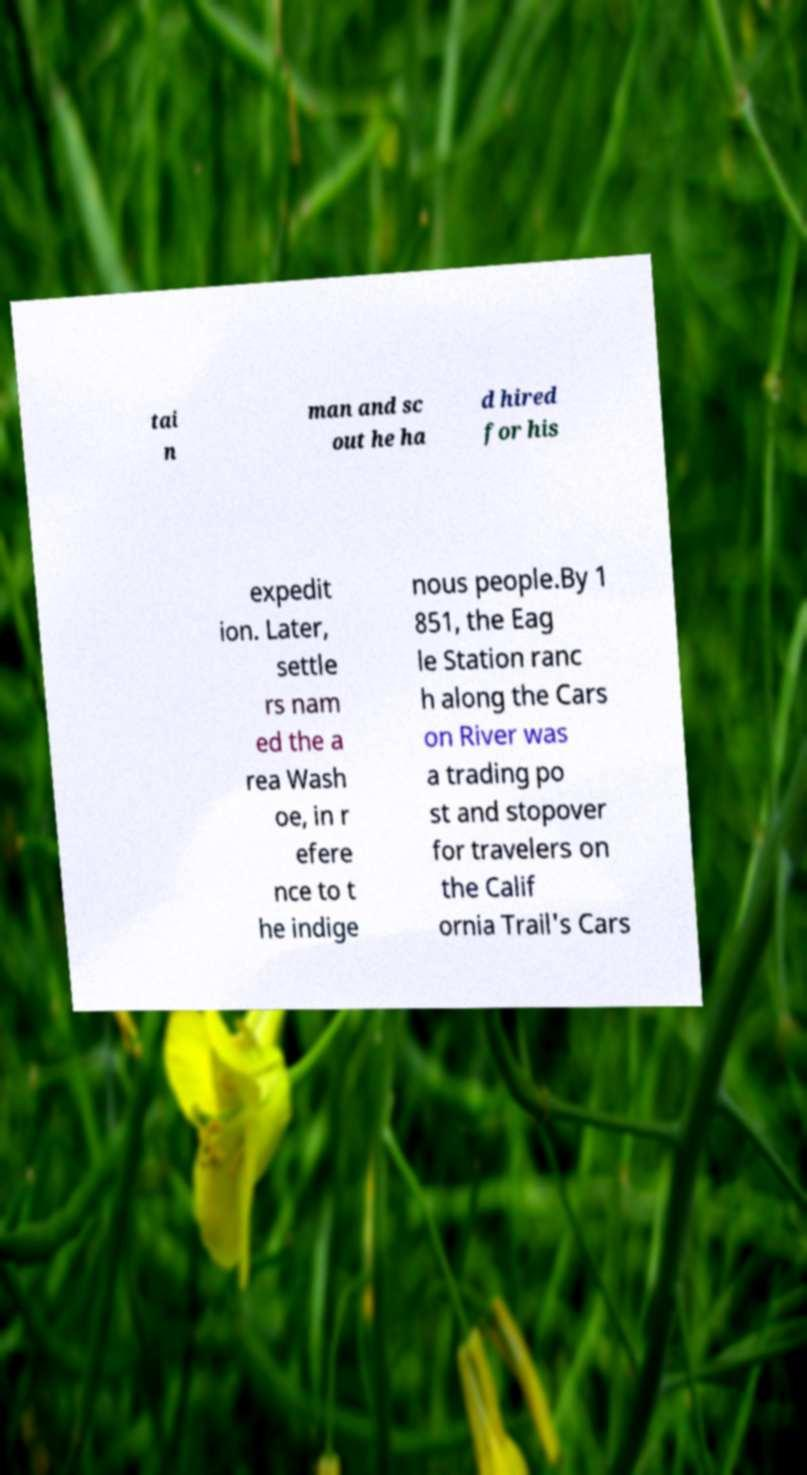Could you extract and type out the text from this image? tai n man and sc out he ha d hired for his expedit ion. Later, settle rs nam ed the a rea Wash oe, in r efere nce to t he indige nous people.By 1 851, the Eag le Station ranc h along the Cars on River was a trading po st and stopover for travelers on the Calif ornia Trail's Cars 